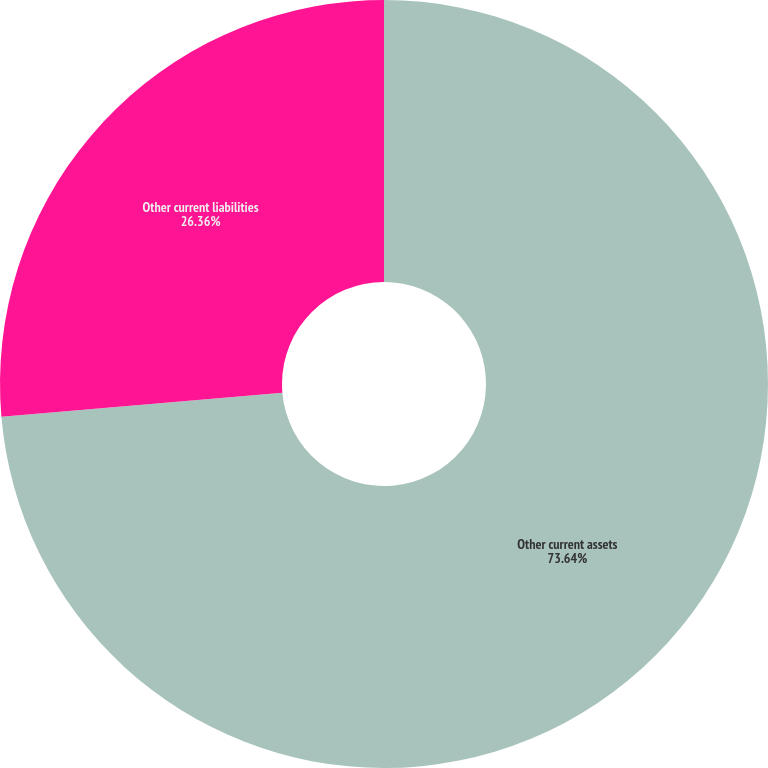Convert chart. <chart><loc_0><loc_0><loc_500><loc_500><pie_chart><fcel>Other current assets<fcel>Other current liabilities<nl><fcel>73.64%<fcel>26.36%<nl></chart> 